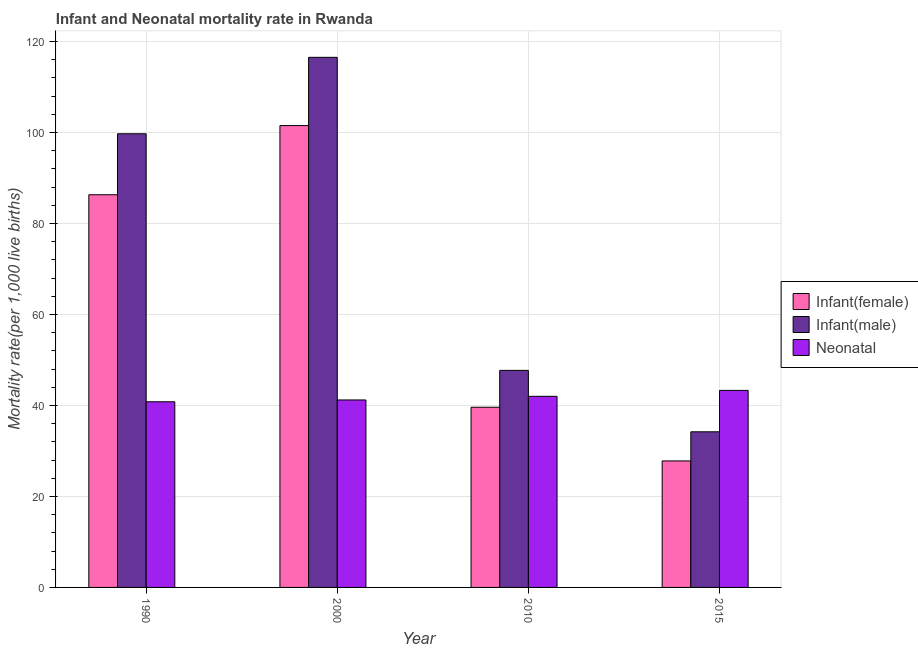How many different coloured bars are there?
Make the answer very short. 3. Are the number of bars per tick equal to the number of legend labels?
Your answer should be compact. Yes. How many bars are there on the 1st tick from the left?
Offer a terse response. 3. What is the infant mortality rate(female) in 2015?
Make the answer very short. 27.8. Across all years, what is the maximum infant mortality rate(female)?
Your answer should be very brief. 101.5. Across all years, what is the minimum infant mortality rate(male)?
Offer a terse response. 34.2. In which year was the infant mortality rate(female) maximum?
Your response must be concise. 2000. In which year was the infant mortality rate(female) minimum?
Provide a short and direct response. 2015. What is the total neonatal mortality rate in the graph?
Offer a very short reply. 167.3. What is the difference between the infant mortality rate(female) in 1990 and that in 2010?
Keep it short and to the point. 46.7. What is the difference between the infant mortality rate(male) in 2015 and the infant mortality rate(female) in 1990?
Give a very brief answer. -65.5. What is the average neonatal mortality rate per year?
Ensure brevity in your answer.  41.83. In the year 2010, what is the difference between the infant mortality rate(female) and infant mortality rate(male)?
Keep it short and to the point. 0. What is the ratio of the neonatal mortality rate in 2000 to that in 2010?
Make the answer very short. 0.98. Is the difference between the infant mortality rate(male) in 2000 and 2015 greater than the difference between the neonatal mortality rate in 2000 and 2015?
Offer a terse response. No. What is the difference between the highest and the second highest infant mortality rate(female)?
Give a very brief answer. 15.2. What is the difference between the highest and the lowest infant mortality rate(female)?
Offer a very short reply. 73.7. Is the sum of the neonatal mortality rate in 1990 and 2000 greater than the maximum infant mortality rate(male) across all years?
Keep it short and to the point. Yes. What does the 3rd bar from the left in 2000 represents?
Your answer should be compact. Neonatal . What does the 1st bar from the right in 2010 represents?
Your answer should be very brief. Neonatal . Is it the case that in every year, the sum of the infant mortality rate(female) and infant mortality rate(male) is greater than the neonatal mortality rate?
Ensure brevity in your answer.  Yes. Are the values on the major ticks of Y-axis written in scientific E-notation?
Your response must be concise. No. Does the graph contain any zero values?
Offer a very short reply. No. Where does the legend appear in the graph?
Make the answer very short. Center right. How many legend labels are there?
Your response must be concise. 3. What is the title of the graph?
Provide a short and direct response. Infant and Neonatal mortality rate in Rwanda. Does "Secondary education" appear as one of the legend labels in the graph?
Provide a succinct answer. No. What is the label or title of the X-axis?
Make the answer very short. Year. What is the label or title of the Y-axis?
Offer a terse response. Mortality rate(per 1,0 live births). What is the Mortality rate(per 1,000 live births) of Infant(female) in 1990?
Your answer should be compact. 86.3. What is the Mortality rate(per 1,000 live births) in Infant(male) in 1990?
Give a very brief answer. 99.7. What is the Mortality rate(per 1,000 live births) of Neonatal  in 1990?
Your response must be concise. 40.8. What is the Mortality rate(per 1,000 live births) in Infant(female) in 2000?
Offer a terse response. 101.5. What is the Mortality rate(per 1,000 live births) in Infant(male) in 2000?
Give a very brief answer. 116.5. What is the Mortality rate(per 1,000 live births) of Neonatal  in 2000?
Your answer should be compact. 41.2. What is the Mortality rate(per 1,000 live births) in Infant(female) in 2010?
Keep it short and to the point. 39.6. What is the Mortality rate(per 1,000 live births) of Infant(male) in 2010?
Your answer should be very brief. 47.7. What is the Mortality rate(per 1,000 live births) in Infant(female) in 2015?
Provide a succinct answer. 27.8. What is the Mortality rate(per 1,000 live births) in Infant(male) in 2015?
Ensure brevity in your answer.  34.2. What is the Mortality rate(per 1,000 live births) in Neonatal  in 2015?
Keep it short and to the point. 43.3. Across all years, what is the maximum Mortality rate(per 1,000 live births) in Infant(female)?
Offer a terse response. 101.5. Across all years, what is the maximum Mortality rate(per 1,000 live births) of Infant(male)?
Provide a succinct answer. 116.5. Across all years, what is the maximum Mortality rate(per 1,000 live births) of Neonatal ?
Provide a short and direct response. 43.3. Across all years, what is the minimum Mortality rate(per 1,000 live births) of Infant(female)?
Offer a very short reply. 27.8. Across all years, what is the minimum Mortality rate(per 1,000 live births) in Infant(male)?
Offer a terse response. 34.2. Across all years, what is the minimum Mortality rate(per 1,000 live births) in Neonatal ?
Make the answer very short. 40.8. What is the total Mortality rate(per 1,000 live births) in Infant(female) in the graph?
Provide a short and direct response. 255.2. What is the total Mortality rate(per 1,000 live births) of Infant(male) in the graph?
Your response must be concise. 298.1. What is the total Mortality rate(per 1,000 live births) in Neonatal  in the graph?
Provide a short and direct response. 167.3. What is the difference between the Mortality rate(per 1,000 live births) in Infant(female) in 1990 and that in 2000?
Offer a very short reply. -15.2. What is the difference between the Mortality rate(per 1,000 live births) of Infant(male) in 1990 and that in 2000?
Make the answer very short. -16.8. What is the difference between the Mortality rate(per 1,000 live births) in Neonatal  in 1990 and that in 2000?
Your answer should be very brief. -0.4. What is the difference between the Mortality rate(per 1,000 live births) in Infant(female) in 1990 and that in 2010?
Make the answer very short. 46.7. What is the difference between the Mortality rate(per 1,000 live births) in Infant(male) in 1990 and that in 2010?
Ensure brevity in your answer.  52. What is the difference between the Mortality rate(per 1,000 live births) of Infant(female) in 1990 and that in 2015?
Provide a short and direct response. 58.5. What is the difference between the Mortality rate(per 1,000 live births) of Infant(male) in 1990 and that in 2015?
Provide a short and direct response. 65.5. What is the difference between the Mortality rate(per 1,000 live births) of Infant(female) in 2000 and that in 2010?
Provide a short and direct response. 61.9. What is the difference between the Mortality rate(per 1,000 live births) of Infant(male) in 2000 and that in 2010?
Your answer should be very brief. 68.8. What is the difference between the Mortality rate(per 1,000 live births) of Neonatal  in 2000 and that in 2010?
Your response must be concise. -0.8. What is the difference between the Mortality rate(per 1,000 live births) in Infant(female) in 2000 and that in 2015?
Keep it short and to the point. 73.7. What is the difference between the Mortality rate(per 1,000 live births) of Infant(male) in 2000 and that in 2015?
Your answer should be very brief. 82.3. What is the difference between the Mortality rate(per 1,000 live births) of Neonatal  in 2000 and that in 2015?
Provide a succinct answer. -2.1. What is the difference between the Mortality rate(per 1,000 live births) in Neonatal  in 2010 and that in 2015?
Ensure brevity in your answer.  -1.3. What is the difference between the Mortality rate(per 1,000 live births) in Infant(female) in 1990 and the Mortality rate(per 1,000 live births) in Infant(male) in 2000?
Give a very brief answer. -30.2. What is the difference between the Mortality rate(per 1,000 live births) in Infant(female) in 1990 and the Mortality rate(per 1,000 live births) in Neonatal  in 2000?
Offer a very short reply. 45.1. What is the difference between the Mortality rate(per 1,000 live births) in Infant(male) in 1990 and the Mortality rate(per 1,000 live births) in Neonatal  in 2000?
Your response must be concise. 58.5. What is the difference between the Mortality rate(per 1,000 live births) of Infant(female) in 1990 and the Mortality rate(per 1,000 live births) of Infant(male) in 2010?
Your response must be concise. 38.6. What is the difference between the Mortality rate(per 1,000 live births) in Infant(female) in 1990 and the Mortality rate(per 1,000 live births) in Neonatal  in 2010?
Your answer should be compact. 44.3. What is the difference between the Mortality rate(per 1,000 live births) in Infant(male) in 1990 and the Mortality rate(per 1,000 live births) in Neonatal  in 2010?
Your answer should be compact. 57.7. What is the difference between the Mortality rate(per 1,000 live births) in Infant(female) in 1990 and the Mortality rate(per 1,000 live births) in Infant(male) in 2015?
Provide a short and direct response. 52.1. What is the difference between the Mortality rate(per 1,000 live births) in Infant(female) in 1990 and the Mortality rate(per 1,000 live births) in Neonatal  in 2015?
Offer a very short reply. 43. What is the difference between the Mortality rate(per 1,000 live births) in Infant(male) in 1990 and the Mortality rate(per 1,000 live births) in Neonatal  in 2015?
Offer a very short reply. 56.4. What is the difference between the Mortality rate(per 1,000 live births) of Infant(female) in 2000 and the Mortality rate(per 1,000 live births) of Infant(male) in 2010?
Offer a terse response. 53.8. What is the difference between the Mortality rate(per 1,000 live births) in Infant(female) in 2000 and the Mortality rate(per 1,000 live births) in Neonatal  in 2010?
Offer a terse response. 59.5. What is the difference between the Mortality rate(per 1,000 live births) of Infant(male) in 2000 and the Mortality rate(per 1,000 live births) of Neonatal  in 2010?
Your answer should be compact. 74.5. What is the difference between the Mortality rate(per 1,000 live births) of Infant(female) in 2000 and the Mortality rate(per 1,000 live births) of Infant(male) in 2015?
Offer a terse response. 67.3. What is the difference between the Mortality rate(per 1,000 live births) in Infant(female) in 2000 and the Mortality rate(per 1,000 live births) in Neonatal  in 2015?
Give a very brief answer. 58.2. What is the difference between the Mortality rate(per 1,000 live births) of Infant(male) in 2000 and the Mortality rate(per 1,000 live births) of Neonatal  in 2015?
Provide a succinct answer. 73.2. What is the difference between the Mortality rate(per 1,000 live births) of Infant(female) in 2010 and the Mortality rate(per 1,000 live births) of Infant(male) in 2015?
Your response must be concise. 5.4. What is the difference between the Mortality rate(per 1,000 live births) in Infant(female) in 2010 and the Mortality rate(per 1,000 live births) in Neonatal  in 2015?
Your answer should be compact. -3.7. What is the difference between the Mortality rate(per 1,000 live births) in Infant(male) in 2010 and the Mortality rate(per 1,000 live births) in Neonatal  in 2015?
Offer a very short reply. 4.4. What is the average Mortality rate(per 1,000 live births) of Infant(female) per year?
Give a very brief answer. 63.8. What is the average Mortality rate(per 1,000 live births) in Infant(male) per year?
Provide a succinct answer. 74.53. What is the average Mortality rate(per 1,000 live births) of Neonatal  per year?
Offer a terse response. 41.83. In the year 1990, what is the difference between the Mortality rate(per 1,000 live births) of Infant(female) and Mortality rate(per 1,000 live births) of Infant(male)?
Your answer should be very brief. -13.4. In the year 1990, what is the difference between the Mortality rate(per 1,000 live births) in Infant(female) and Mortality rate(per 1,000 live births) in Neonatal ?
Your answer should be compact. 45.5. In the year 1990, what is the difference between the Mortality rate(per 1,000 live births) of Infant(male) and Mortality rate(per 1,000 live births) of Neonatal ?
Offer a terse response. 58.9. In the year 2000, what is the difference between the Mortality rate(per 1,000 live births) in Infant(female) and Mortality rate(per 1,000 live births) in Infant(male)?
Your response must be concise. -15. In the year 2000, what is the difference between the Mortality rate(per 1,000 live births) of Infant(female) and Mortality rate(per 1,000 live births) of Neonatal ?
Give a very brief answer. 60.3. In the year 2000, what is the difference between the Mortality rate(per 1,000 live births) in Infant(male) and Mortality rate(per 1,000 live births) in Neonatal ?
Ensure brevity in your answer.  75.3. In the year 2010, what is the difference between the Mortality rate(per 1,000 live births) of Infant(female) and Mortality rate(per 1,000 live births) of Infant(male)?
Provide a short and direct response. -8.1. In the year 2010, what is the difference between the Mortality rate(per 1,000 live births) of Infant(female) and Mortality rate(per 1,000 live births) of Neonatal ?
Give a very brief answer. -2.4. In the year 2010, what is the difference between the Mortality rate(per 1,000 live births) in Infant(male) and Mortality rate(per 1,000 live births) in Neonatal ?
Make the answer very short. 5.7. In the year 2015, what is the difference between the Mortality rate(per 1,000 live births) in Infant(female) and Mortality rate(per 1,000 live births) in Infant(male)?
Keep it short and to the point. -6.4. In the year 2015, what is the difference between the Mortality rate(per 1,000 live births) in Infant(female) and Mortality rate(per 1,000 live births) in Neonatal ?
Keep it short and to the point. -15.5. What is the ratio of the Mortality rate(per 1,000 live births) in Infant(female) in 1990 to that in 2000?
Offer a terse response. 0.85. What is the ratio of the Mortality rate(per 1,000 live births) of Infant(male) in 1990 to that in 2000?
Your response must be concise. 0.86. What is the ratio of the Mortality rate(per 1,000 live births) of Neonatal  in 1990 to that in 2000?
Offer a terse response. 0.99. What is the ratio of the Mortality rate(per 1,000 live births) of Infant(female) in 1990 to that in 2010?
Offer a terse response. 2.18. What is the ratio of the Mortality rate(per 1,000 live births) of Infant(male) in 1990 to that in 2010?
Ensure brevity in your answer.  2.09. What is the ratio of the Mortality rate(per 1,000 live births) of Neonatal  in 1990 to that in 2010?
Give a very brief answer. 0.97. What is the ratio of the Mortality rate(per 1,000 live births) in Infant(female) in 1990 to that in 2015?
Keep it short and to the point. 3.1. What is the ratio of the Mortality rate(per 1,000 live births) of Infant(male) in 1990 to that in 2015?
Provide a short and direct response. 2.92. What is the ratio of the Mortality rate(per 1,000 live births) in Neonatal  in 1990 to that in 2015?
Keep it short and to the point. 0.94. What is the ratio of the Mortality rate(per 1,000 live births) in Infant(female) in 2000 to that in 2010?
Keep it short and to the point. 2.56. What is the ratio of the Mortality rate(per 1,000 live births) of Infant(male) in 2000 to that in 2010?
Your answer should be compact. 2.44. What is the ratio of the Mortality rate(per 1,000 live births) of Infant(female) in 2000 to that in 2015?
Provide a succinct answer. 3.65. What is the ratio of the Mortality rate(per 1,000 live births) in Infant(male) in 2000 to that in 2015?
Your answer should be compact. 3.41. What is the ratio of the Mortality rate(per 1,000 live births) in Neonatal  in 2000 to that in 2015?
Give a very brief answer. 0.95. What is the ratio of the Mortality rate(per 1,000 live births) in Infant(female) in 2010 to that in 2015?
Provide a succinct answer. 1.42. What is the ratio of the Mortality rate(per 1,000 live births) in Infant(male) in 2010 to that in 2015?
Offer a terse response. 1.39. What is the ratio of the Mortality rate(per 1,000 live births) in Neonatal  in 2010 to that in 2015?
Give a very brief answer. 0.97. What is the difference between the highest and the second highest Mortality rate(per 1,000 live births) of Infant(female)?
Make the answer very short. 15.2. What is the difference between the highest and the second highest Mortality rate(per 1,000 live births) of Neonatal ?
Keep it short and to the point. 1.3. What is the difference between the highest and the lowest Mortality rate(per 1,000 live births) in Infant(female)?
Make the answer very short. 73.7. What is the difference between the highest and the lowest Mortality rate(per 1,000 live births) of Infant(male)?
Offer a very short reply. 82.3. What is the difference between the highest and the lowest Mortality rate(per 1,000 live births) in Neonatal ?
Your answer should be compact. 2.5. 